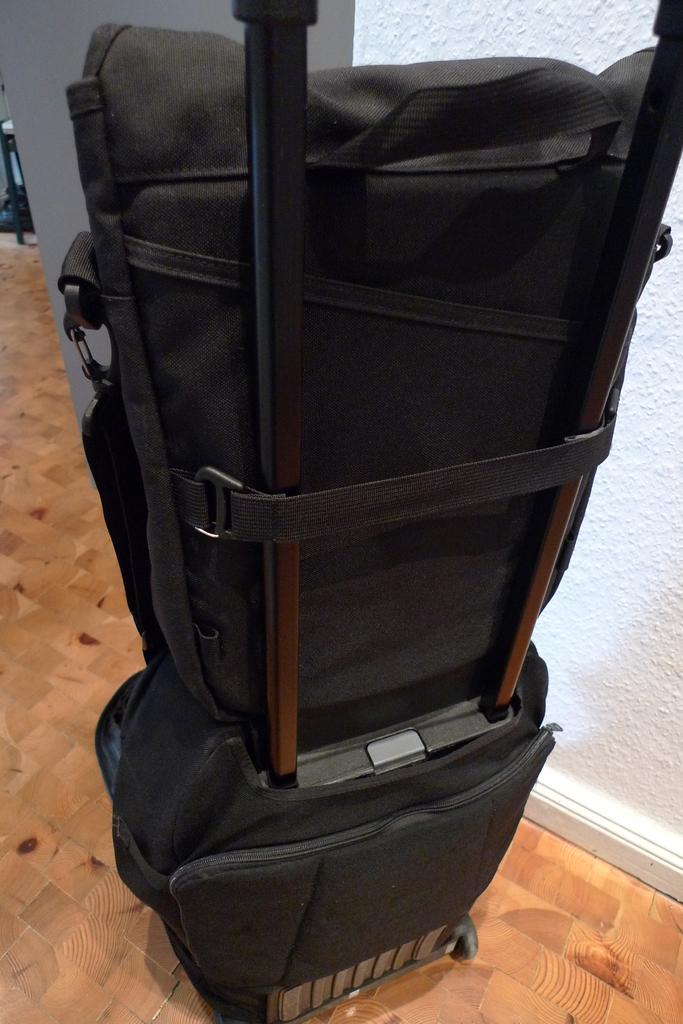What is on the floor in the image? There are bags on the floor in the image. What color are the walls in the background of the image? The background of the image includes white color walls. Can you describe any other objects visible in the background of the image? There are other objects visible in the background of the image, but their specific details are not mentioned in the provided facts. What position do the hands of the person in the image hold the frame? There is no person or frame present in the image; it only shows bags on the floor and white walls in the background. 